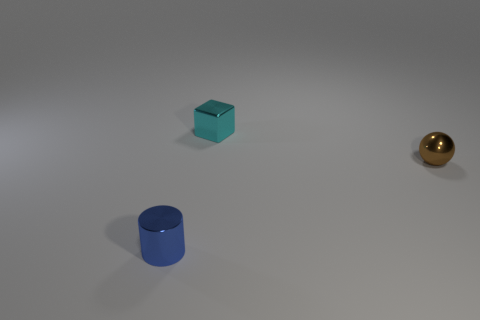Are there more tiny objects left of the cylinder than brown objects?
Your response must be concise. No. What is the material of the blue cylinder?
Make the answer very short. Metal. The brown thing that is the same material as the tiny cylinder is what shape?
Offer a terse response. Sphere. There is a thing that is right of the small metal object behind the small brown object; what is its size?
Offer a very short reply. Small. There is a small shiny object right of the tiny cyan block; what is its color?
Your response must be concise. Brown. Are there any gray things of the same shape as the cyan metal thing?
Provide a short and direct response. No. Are there fewer cylinders behind the small blue object than tiny metal cylinders behind the small brown metal sphere?
Ensure brevity in your answer.  No. The small cube is what color?
Ensure brevity in your answer.  Cyan. Is there a blue shiny cylinder that is to the right of the object in front of the brown thing?
Your answer should be compact. No. What number of cylinders have the same size as the cyan cube?
Keep it short and to the point. 1. 